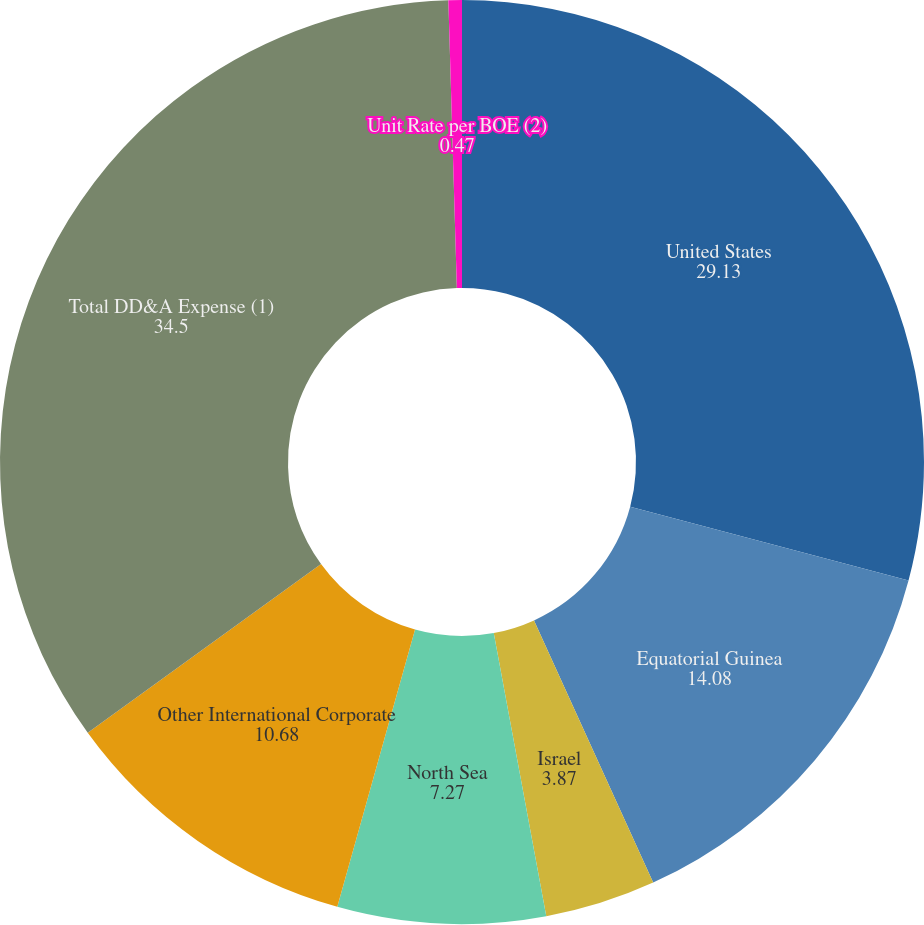Convert chart. <chart><loc_0><loc_0><loc_500><loc_500><pie_chart><fcel>United States<fcel>Equatorial Guinea<fcel>Israel<fcel>North Sea<fcel>Other International Corporate<fcel>Total DD&A Expense (1)<fcel>Unit Rate per BOE (2)<nl><fcel>29.13%<fcel>14.08%<fcel>3.87%<fcel>7.27%<fcel>10.68%<fcel>34.5%<fcel>0.47%<nl></chart> 